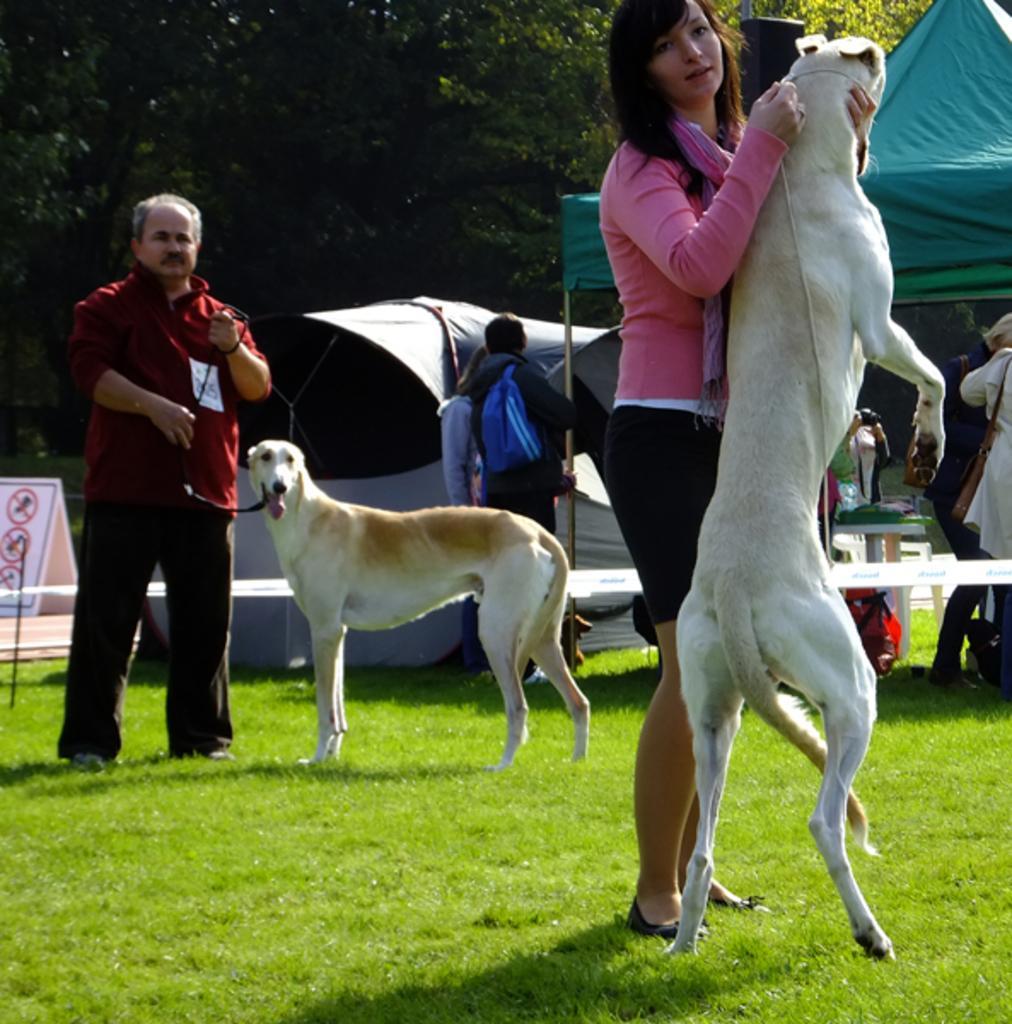How would you summarize this image in a sentence or two? On the left there is a woman holding dog. On the right there is a man holding belt which is tied to dog. In the background there are people,tent and trees. 